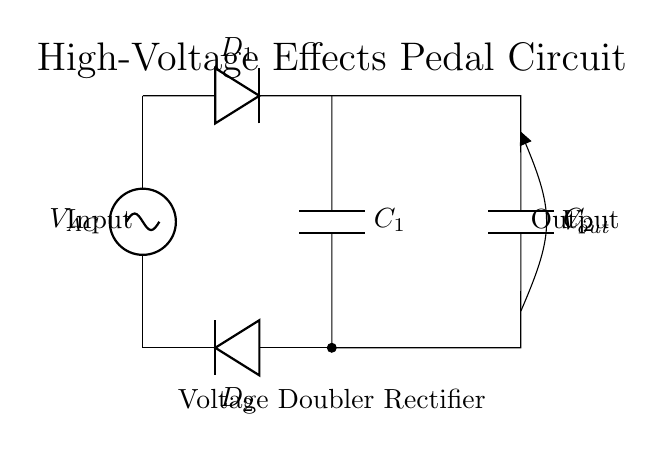What is the input voltage for this circuit? The input voltage is labeled as V_AC in the diagram, indicating that it is the alternating current source feeding into the circuit.
Answer: V_AC How many diodes are used in this circuit? The diagram shows two diodes labeled D1 and D2, which are components essential for the rectification process in this circuit.
Answer: 2 What components are used for storing charge in this circuit? The circuit diagram includes two capacitors labeled C1 and C2, which are used to store electrical energy and smooth out the rectified voltage.
Answer: C1, C2 What is the function of the diodes in this circuit? The diodes D1 and D2 allow current to flow in one direction only, facilitating the rectification process that changes AC to DC, while preventing reverse flow.
Answer: Rectification What is the output voltage of the circuit relative to the input voltage? In a voltage doubler circuit, the output voltage is theoretically double the input voltage, assuming ideal components and conditions.
Answer: 2 * V_AC What is the role of the capacitors in this voltage doubler rectifier circuit? The capacitors C1 and C2 charge up to the peak voltage and help to increase the output voltage to a value close to double the input while smoothing the output waveform to reduce ripple.
Answer: Voltage doubling and smoothing 